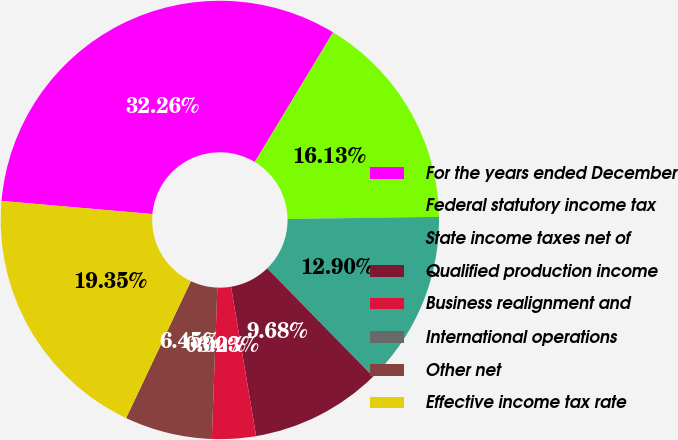Convert chart to OTSL. <chart><loc_0><loc_0><loc_500><loc_500><pie_chart><fcel>For the years ended December<fcel>Federal statutory income tax<fcel>State income taxes net of<fcel>Qualified production income<fcel>Business realignment and<fcel>International operations<fcel>Other net<fcel>Effective income tax rate<nl><fcel>32.26%<fcel>16.13%<fcel>12.9%<fcel>9.68%<fcel>3.23%<fcel>0.0%<fcel>6.45%<fcel>19.35%<nl></chart> 